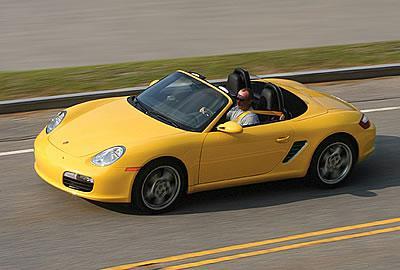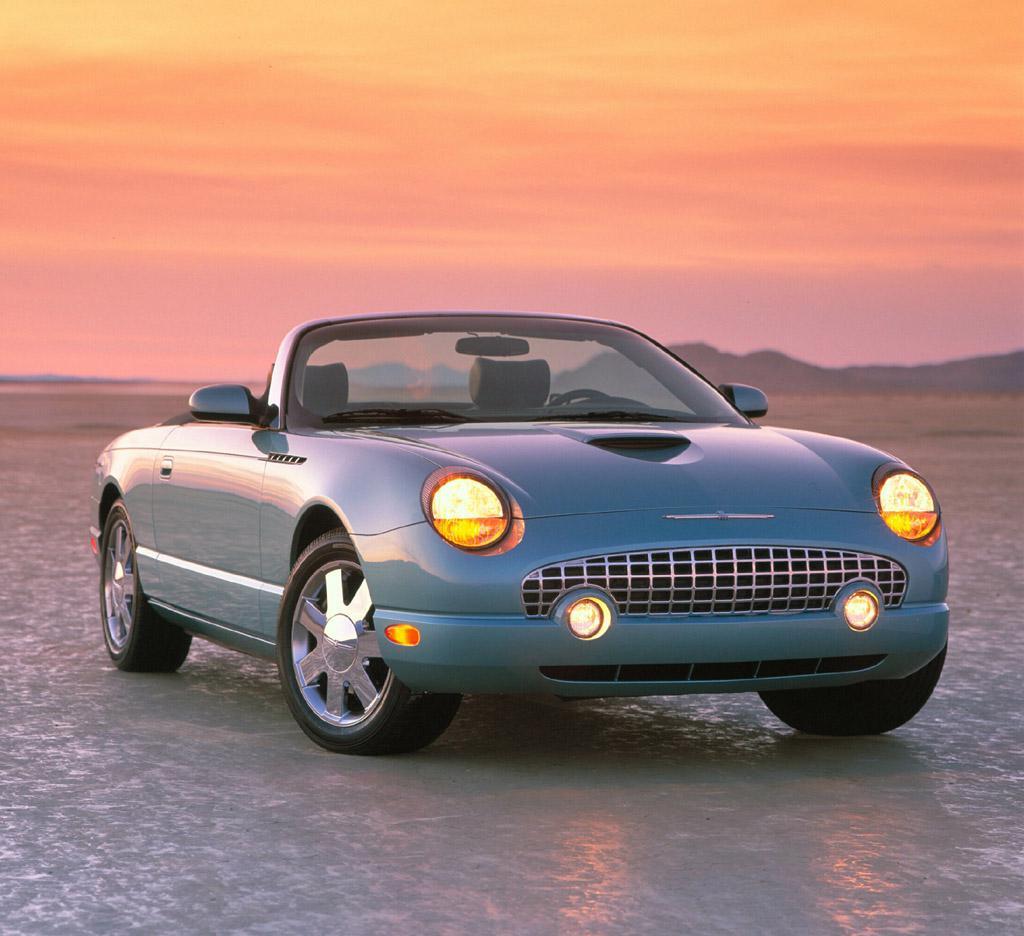The first image is the image on the left, the second image is the image on the right. Analyze the images presented: Is the assertion "There Is a single apple red car with the top down and thin tires facing left on the road." valid? Answer yes or no. No. The first image is the image on the left, the second image is the image on the right. Analyze the images presented: Is the assertion "There is a blue car facing right in the right image." valid? Answer yes or no. Yes. 